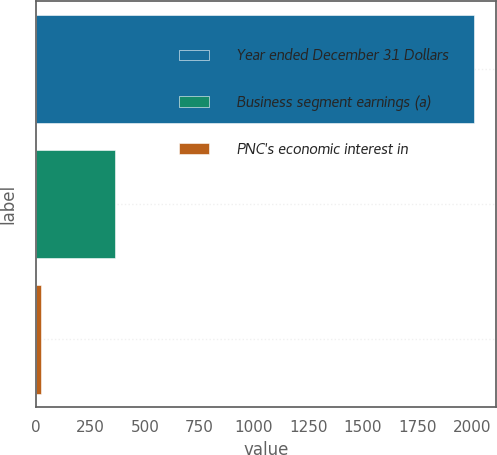<chart> <loc_0><loc_0><loc_500><loc_500><bar_chart><fcel>Year ended December 31 Dollars<fcel>Business segment earnings (a)<fcel>PNC's economic interest in<nl><fcel>2011<fcel>361<fcel>21<nl></chart> 